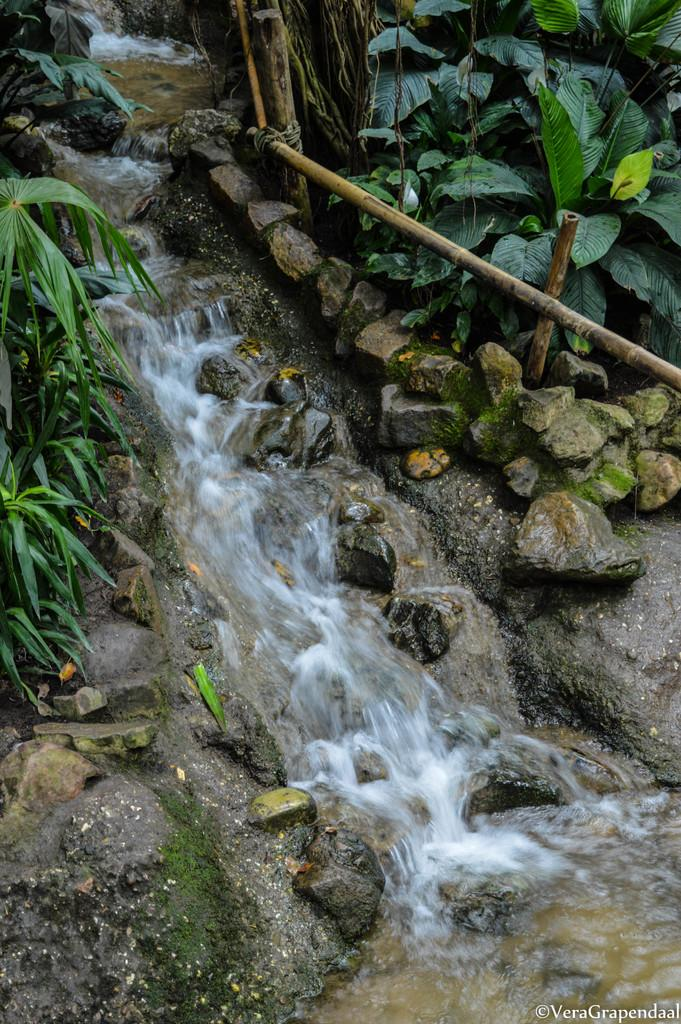What natural feature is the main subject of the image? There is a waterfall in the image. What type of geological formation can be seen near the waterfall? Rocks are present in the image. Is there any man-made structure visible in the image? Yes, there is a fence in the image. What type of vegetation is visible on both sides of the image? Plants are visible on the left side and the right side of the image. Is there any additional information or marking on the image? Yes, there is a watermark in the bottom right corner of the image. What type of butter is being used to create the print on the rocks in the image? There is no butter or print on the rocks in the image; they are natural geological formations. 